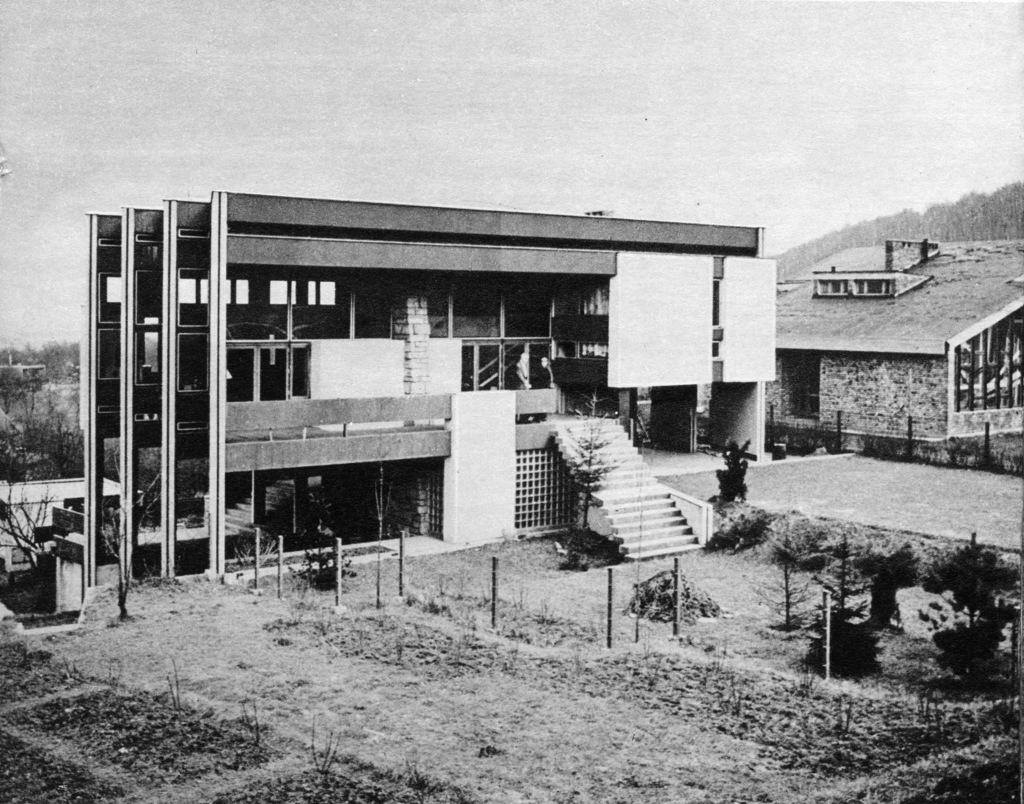What type of structures can be seen in the image? There are buildings in the image. What natural elements are present in the image? There are trees and plants in the image. What geographical feature is visible in the image? There is a hill visible in the image. What type of soup is being served in the image? There is no soup present in the image. Can you see an owl perched on one of the trees in the image? There is no owl visible in the image. 